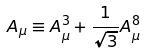Convert formula to latex. <formula><loc_0><loc_0><loc_500><loc_500>A _ { \mu } \equiv A ^ { 3 } _ { \mu } + { \frac { 1 } { \sqrt { 3 } } } A ^ { 8 } _ { \mu }</formula> 